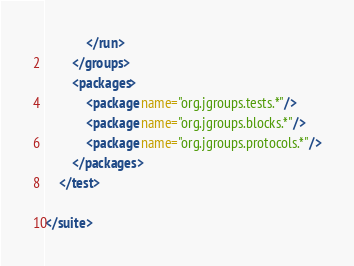Convert code to text. <code><loc_0><loc_0><loc_500><loc_500><_XML_>            </run>
        </groups>
        <packages>
            <package name="org.jgroups.tests.*"/>
            <package name="org.jgroups.blocks.*"/>
            <package name="org.jgroups.protocols.*"/>
        </packages>
    </test>

</suite>
</code> 